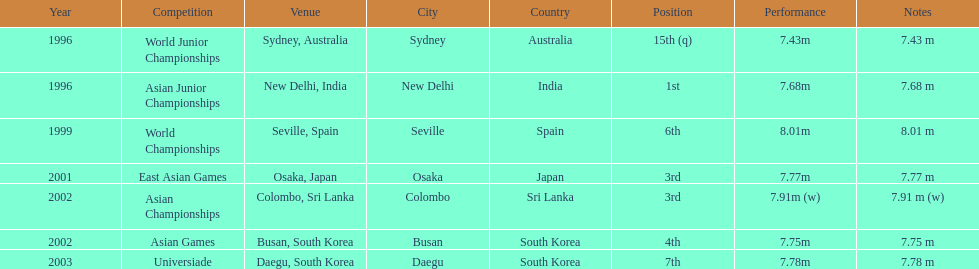How many times did his jump surpass 7.70 m? 5. 